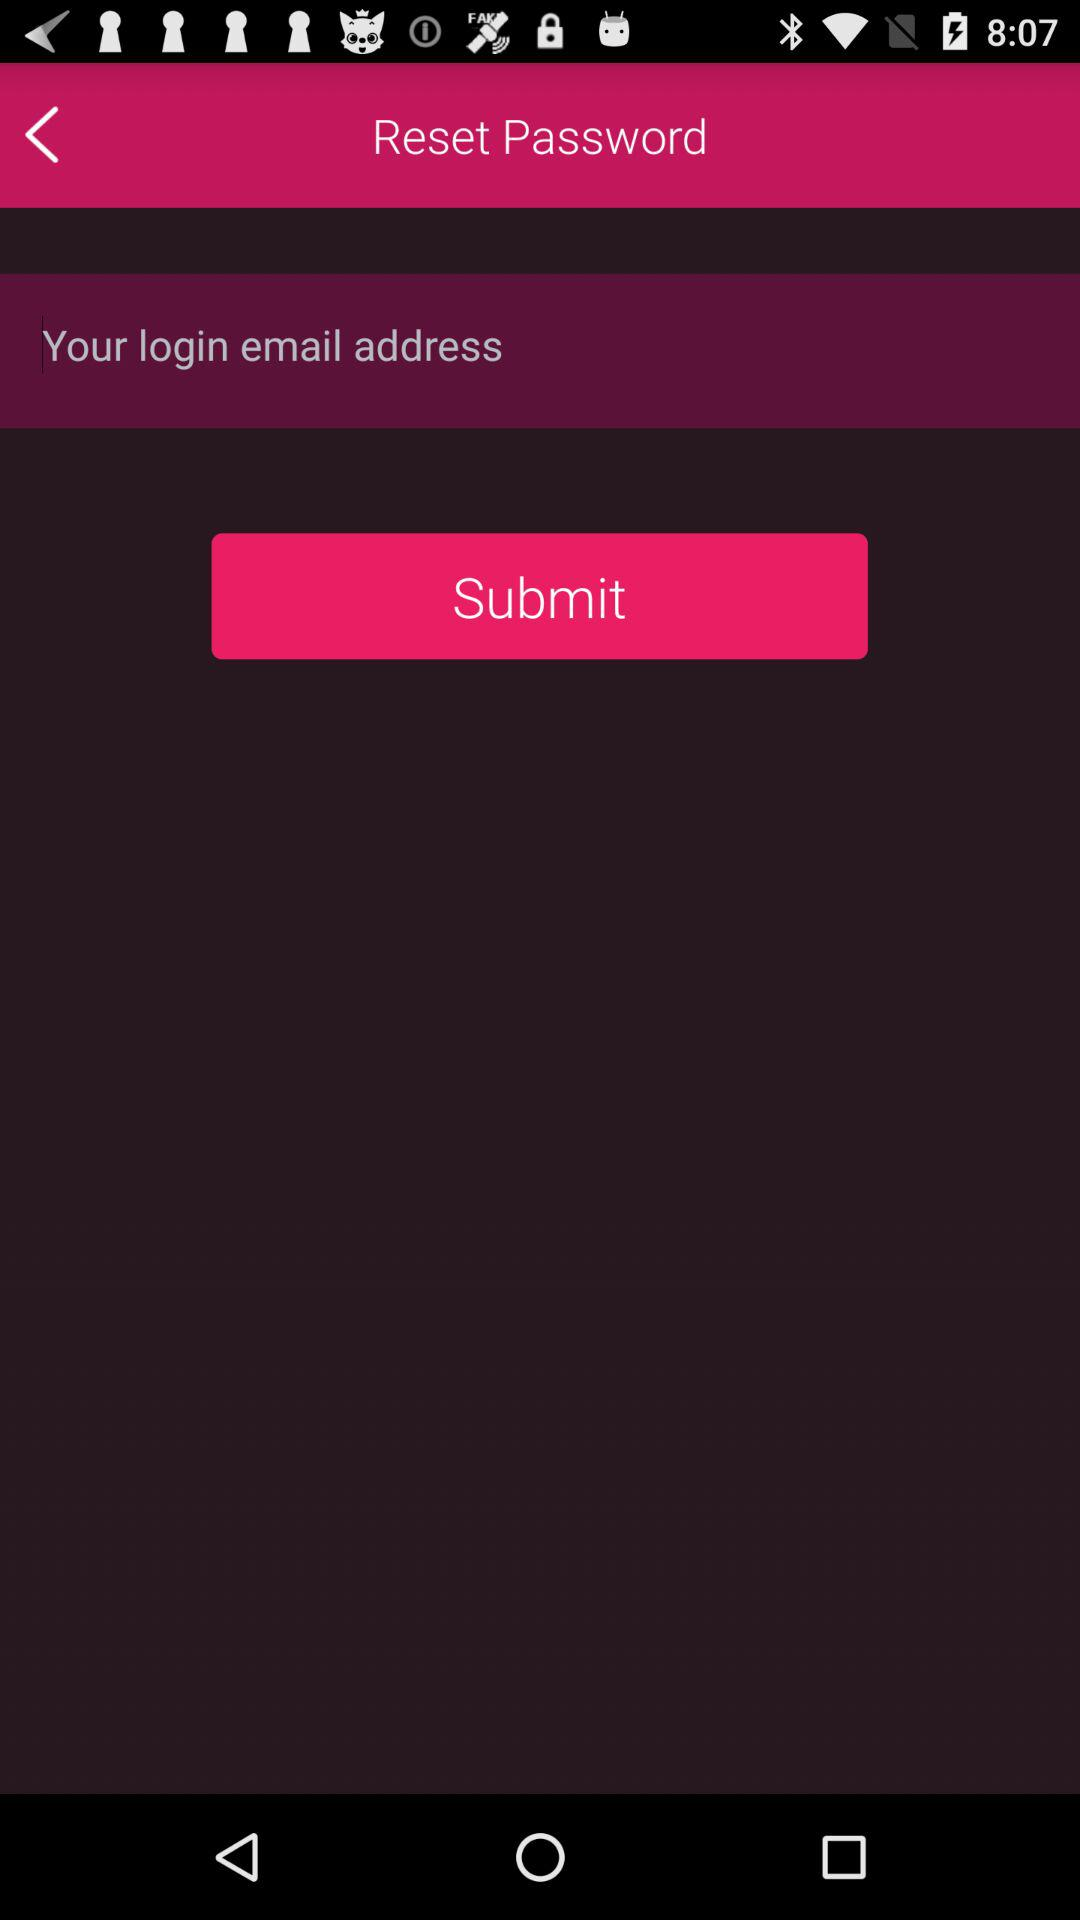What is the requirement to reset the password? The requirement is your login email address. 